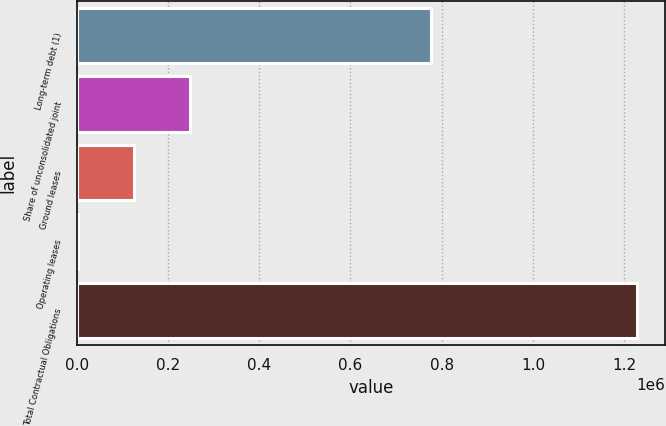Convert chart. <chart><loc_0><loc_0><loc_500><loc_500><bar_chart><fcel>Long-term debt (1)<fcel>Share of unconsolidated joint<fcel>Ground leases<fcel>Operating leases<fcel>Total Contractual Obligations<nl><fcel>777490<fcel>247781<fcel>125210<fcel>2638<fcel>1.22836e+06<nl></chart> 